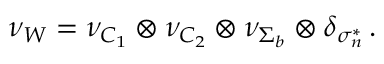<formula> <loc_0><loc_0><loc_500><loc_500>\nu _ { W } = \nu _ { C _ { 1 } } \otimes \nu _ { C _ { 2 } } \otimes \nu _ { \Sigma _ { b } } \otimes \delta _ { \sigma _ { n } ^ { * } } \, .</formula> 